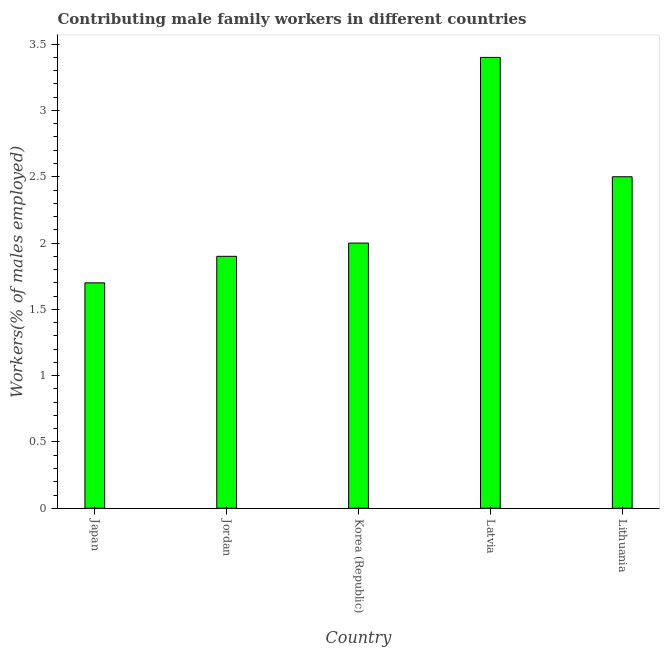Does the graph contain any zero values?
Make the answer very short. No. What is the title of the graph?
Make the answer very short. Contributing male family workers in different countries. What is the label or title of the Y-axis?
Provide a short and direct response. Workers(% of males employed). What is the contributing male family workers in Japan?
Offer a very short reply. 1.7. Across all countries, what is the maximum contributing male family workers?
Provide a succinct answer. 3.4. Across all countries, what is the minimum contributing male family workers?
Your answer should be compact. 1.7. In which country was the contributing male family workers maximum?
Give a very brief answer. Latvia. In which country was the contributing male family workers minimum?
Provide a succinct answer. Japan. What is the sum of the contributing male family workers?
Provide a short and direct response. 11.5. What is the average contributing male family workers per country?
Your answer should be compact. 2.3. In how many countries, is the contributing male family workers greater than 0.2 %?
Ensure brevity in your answer.  5. Is the contributing male family workers in Jordan less than that in Korea (Republic)?
Provide a succinct answer. Yes. Is the sum of the contributing male family workers in Korea (Republic) and Lithuania greater than the maximum contributing male family workers across all countries?
Offer a very short reply. Yes. What is the difference between the highest and the lowest contributing male family workers?
Offer a very short reply. 1.7. Are all the bars in the graph horizontal?
Provide a succinct answer. No. What is the difference between two consecutive major ticks on the Y-axis?
Make the answer very short. 0.5. Are the values on the major ticks of Y-axis written in scientific E-notation?
Provide a short and direct response. No. What is the Workers(% of males employed) in Japan?
Offer a terse response. 1.7. What is the Workers(% of males employed) in Jordan?
Your answer should be very brief. 1.9. What is the Workers(% of males employed) of Latvia?
Provide a short and direct response. 3.4. What is the Workers(% of males employed) in Lithuania?
Give a very brief answer. 2.5. What is the difference between the Workers(% of males employed) in Japan and Korea (Republic)?
Offer a terse response. -0.3. What is the difference between the Workers(% of males employed) in Japan and Latvia?
Offer a terse response. -1.7. What is the difference between the Workers(% of males employed) in Japan and Lithuania?
Make the answer very short. -0.8. What is the difference between the Workers(% of males employed) in Korea (Republic) and Lithuania?
Your answer should be very brief. -0.5. What is the difference between the Workers(% of males employed) in Latvia and Lithuania?
Ensure brevity in your answer.  0.9. What is the ratio of the Workers(% of males employed) in Japan to that in Jordan?
Your response must be concise. 0.9. What is the ratio of the Workers(% of males employed) in Japan to that in Korea (Republic)?
Offer a very short reply. 0.85. What is the ratio of the Workers(% of males employed) in Japan to that in Latvia?
Give a very brief answer. 0.5. What is the ratio of the Workers(% of males employed) in Japan to that in Lithuania?
Offer a very short reply. 0.68. What is the ratio of the Workers(% of males employed) in Jordan to that in Korea (Republic)?
Keep it short and to the point. 0.95. What is the ratio of the Workers(% of males employed) in Jordan to that in Latvia?
Provide a short and direct response. 0.56. What is the ratio of the Workers(% of males employed) in Jordan to that in Lithuania?
Offer a terse response. 0.76. What is the ratio of the Workers(% of males employed) in Korea (Republic) to that in Latvia?
Keep it short and to the point. 0.59. What is the ratio of the Workers(% of males employed) in Latvia to that in Lithuania?
Your response must be concise. 1.36. 